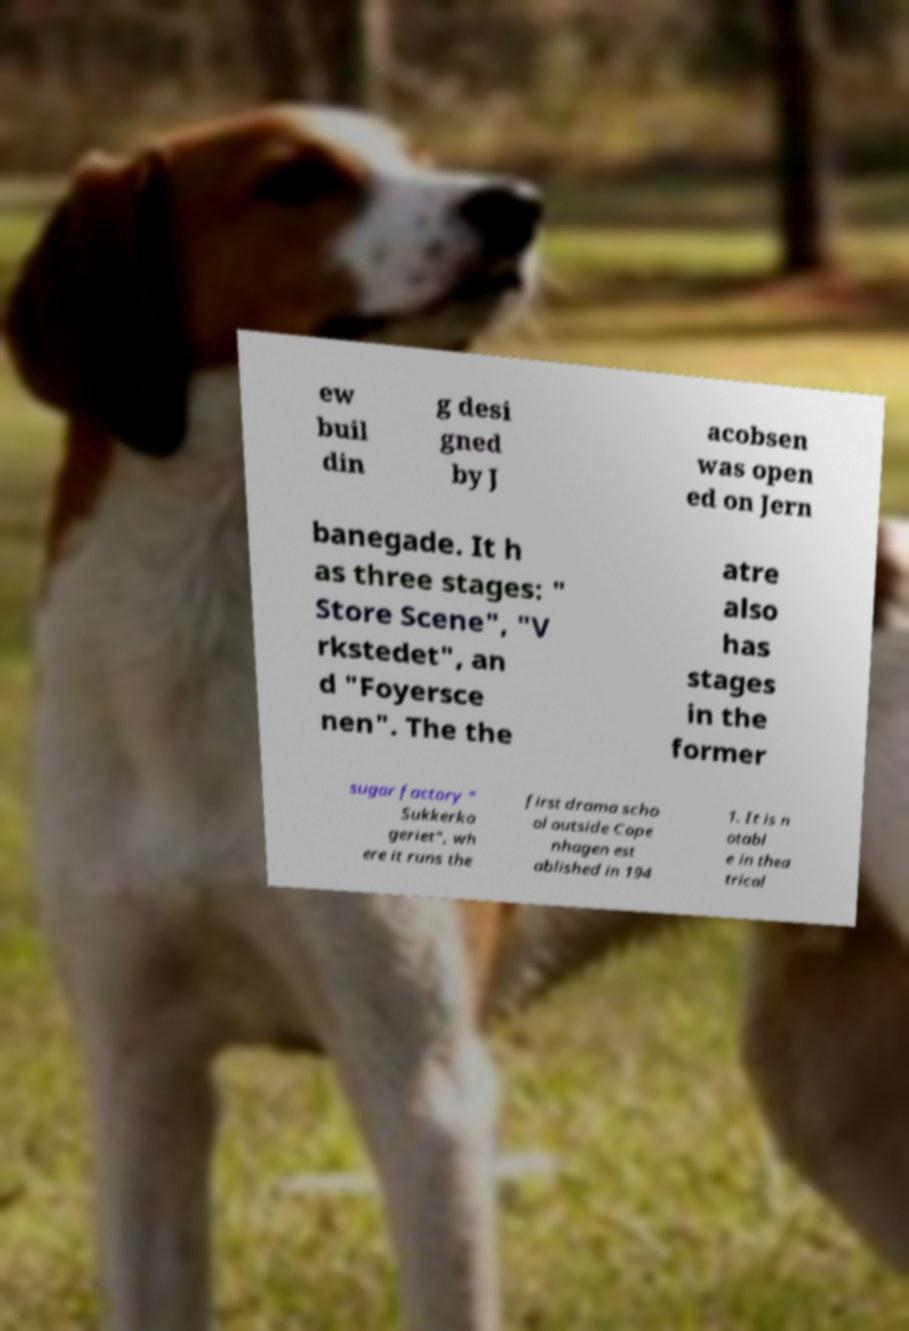Can you read and provide the text displayed in the image?This photo seems to have some interesting text. Can you extract and type it out for me? ew buil din g desi gned by J acobsen was open ed on Jern banegade. It h as three stages: " Store Scene", "V rkstedet", an d "Foyersce nen". The the atre also has stages in the former sugar factory " Sukkerko geriet", wh ere it runs the first drama scho ol outside Cope nhagen est ablished in 194 1. It is n otabl e in thea trical 